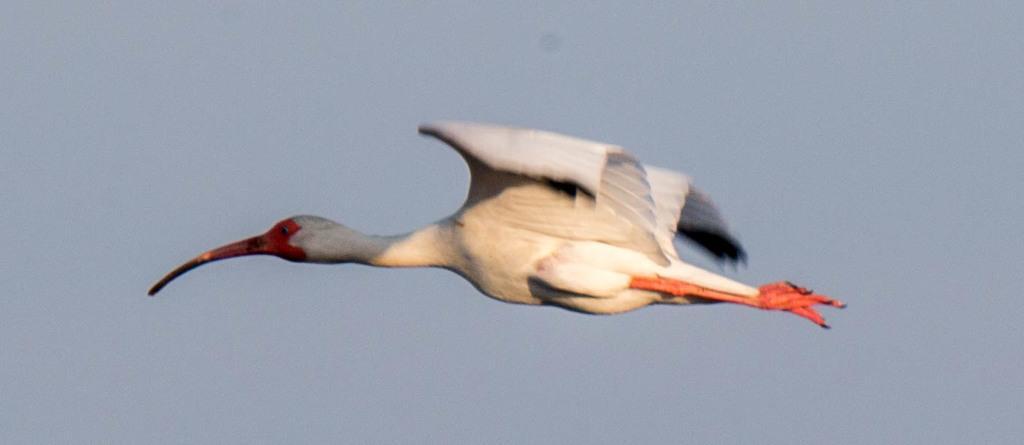In one or two sentences, can you explain what this image depicts? Here I can see a white color bird is flying in the air towards the left side. In the background, I can see the sky. 